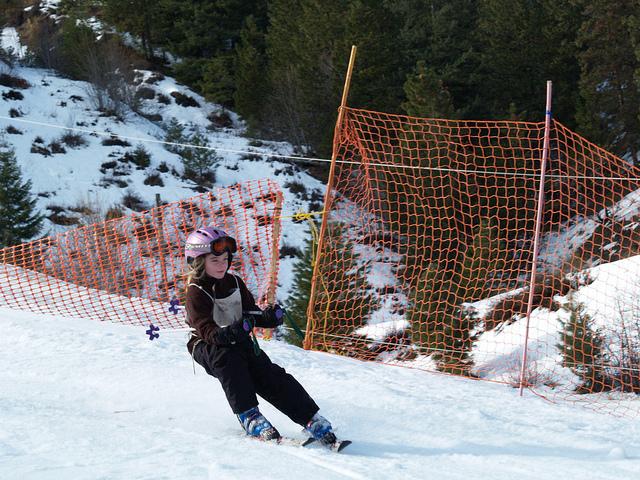What color is the fence?
Keep it brief. Orange. How many nets are there?
Write a very short answer. 2. What is white in the photo?
Concise answer only. Snow. 